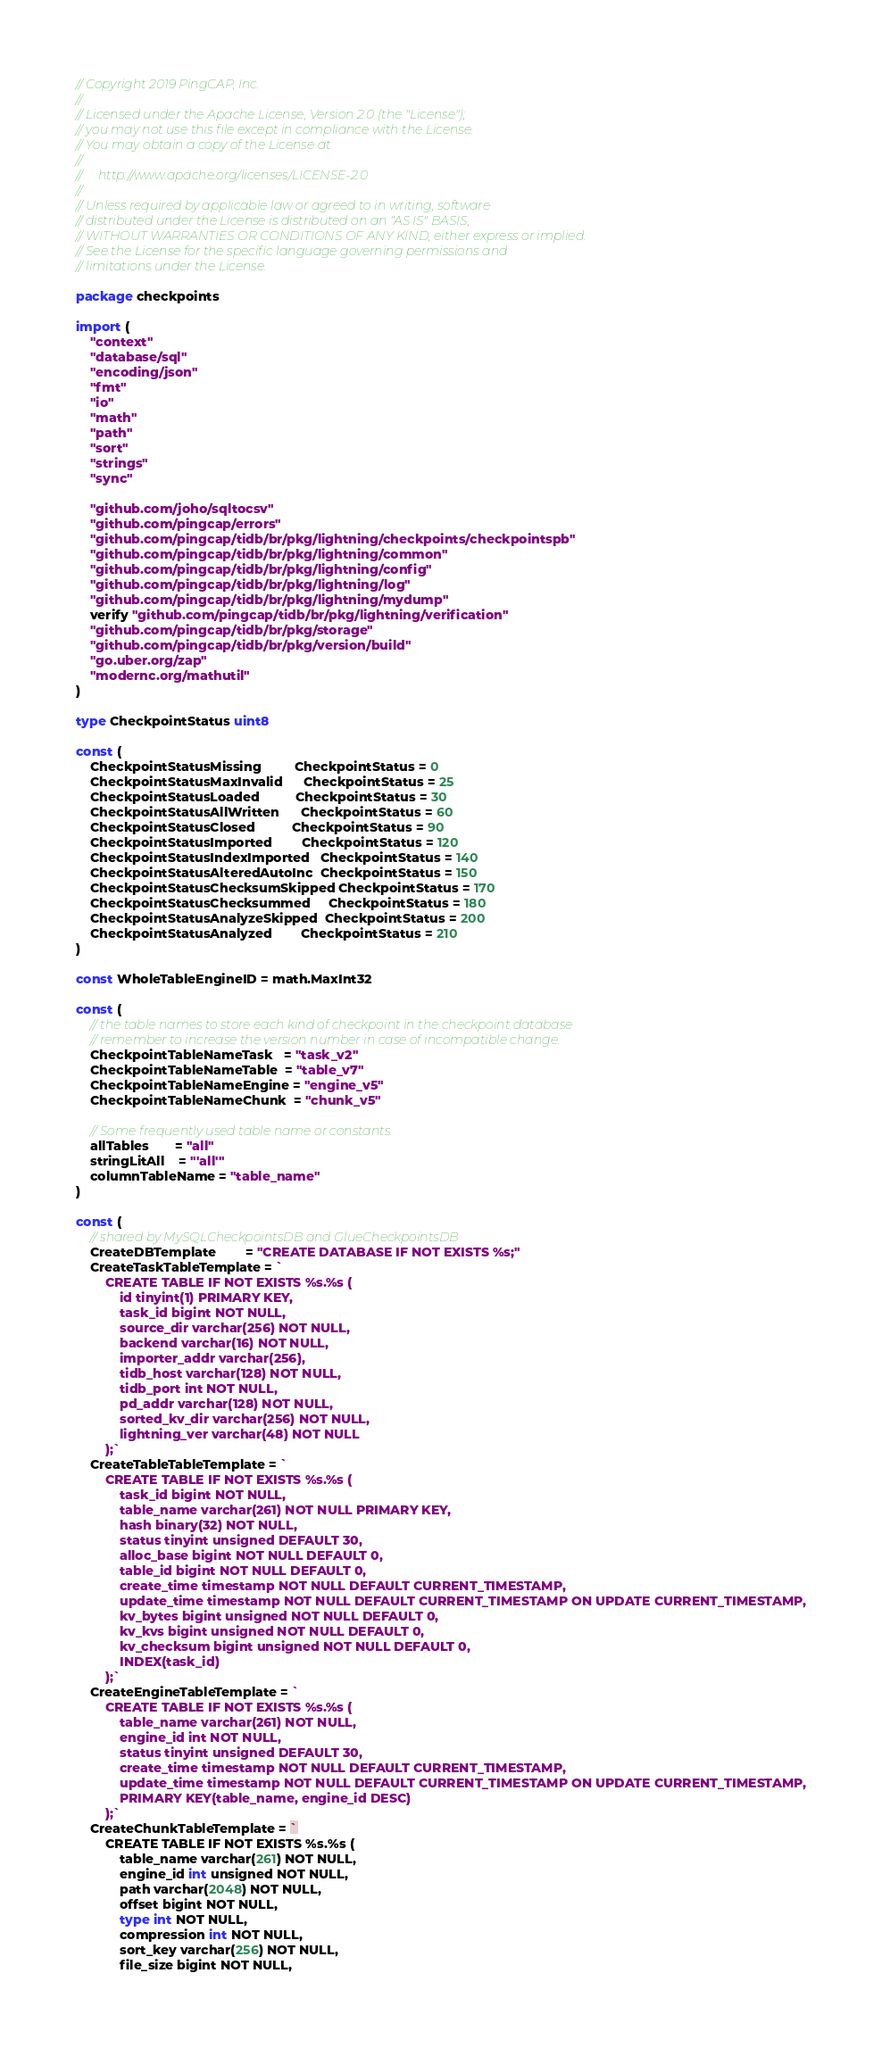Convert code to text. <code><loc_0><loc_0><loc_500><loc_500><_Go_>// Copyright 2019 PingCAP, Inc.
//
// Licensed under the Apache License, Version 2.0 (the "License");
// you may not use this file except in compliance with the License.
// You may obtain a copy of the License at
//
//     http://www.apache.org/licenses/LICENSE-2.0
//
// Unless required by applicable law or agreed to in writing, software
// distributed under the License is distributed on an "AS IS" BASIS,
// WITHOUT WARRANTIES OR CONDITIONS OF ANY KIND, either express or implied.
// See the License for the specific language governing permissions and
// limitations under the License.

package checkpoints

import (
	"context"
	"database/sql"
	"encoding/json"
	"fmt"
	"io"
	"math"
	"path"
	"sort"
	"strings"
	"sync"

	"github.com/joho/sqltocsv"
	"github.com/pingcap/errors"
	"github.com/pingcap/tidb/br/pkg/lightning/checkpoints/checkpointspb"
	"github.com/pingcap/tidb/br/pkg/lightning/common"
	"github.com/pingcap/tidb/br/pkg/lightning/config"
	"github.com/pingcap/tidb/br/pkg/lightning/log"
	"github.com/pingcap/tidb/br/pkg/lightning/mydump"
	verify "github.com/pingcap/tidb/br/pkg/lightning/verification"
	"github.com/pingcap/tidb/br/pkg/storage"
	"github.com/pingcap/tidb/br/pkg/version/build"
	"go.uber.org/zap"
	"modernc.org/mathutil"
)

type CheckpointStatus uint8

const (
	CheckpointStatusMissing         CheckpointStatus = 0
	CheckpointStatusMaxInvalid      CheckpointStatus = 25
	CheckpointStatusLoaded          CheckpointStatus = 30
	CheckpointStatusAllWritten      CheckpointStatus = 60
	CheckpointStatusClosed          CheckpointStatus = 90
	CheckpointStatusImported        CheckpointStatus = 120
	CheckpointStatusIndexImported   CheckpointStatus = 140
	CheckpointStatusAlteredAutoInc  CheckpointStatus = 150
	CheckpointStatusChecksumSkipped CheckpointStatus = 170
	CheckpointStatusChecksummed     CheckpointStatus = 180
	CheckpointStatusAnalyzeSkipped  CheckpointStatus = 200
	CheckpointStatusAnalyzed        CheckpointStatus = 210
)

const WholeTableEngineID = math.MaxInt32

const (
	// the table names to store each kind of checkpoint in the checkpoint database
	// remember to increase the version number in case of incompatible change.
	CheckpointTableNameTask   = "task_v2"
	CheckpointTableNameTable  = "table_v7"
	CheckpointTableNameEngine = "engine_v5"
	CheckpointTableNameChunk  = "chunk_v5"

	// Some frequently used table name or constants.
	allTables       = "all"
	stringLitAll    = "'all'"
	columnTableName = "table_name"
)

const (
	// shared by MySQLCheckpointsDB and GlueCheckpointsDB
	CreateDBTemplate        = "CREATE DATABASE IF NOT EXISTS %s;"
	CreateTaskTableTemplate = `
		CREATE TABLE IF NOT EXISTS %s.%s (
			id tinyint(1) PRIMARY KEY,
			task_id bigint NOT NULL,
			source_dir varchar(256) NOT NULL,
			backend varchar(16) NOT NULL,
			importer_addr varchar(256),
			tidb_host varchar(128) NOT NULL,
			tidb_port int NOT NULL,
			pd_addr varchar(128) NOT NULL,
			sorted_kv_dir varchar(256) NOT NULL,
			lightning_ver varchar(48) NOT NULL
		);`
	CreateTableTableTemplate = `
		CREATE TABLE IF NOT EXISTS %s.%s (
			task_id bigint NOT NULL,
			table_name varchar(261) NOT NULL PRIMARY KEY,
			hash binary(32) NOT NULL,
			status tinyint unsigned DEFAULT 30,
			alloc_base bigint NOT NULL DEFAULT 0,
			table_id bigint NOT NULL DEFAULT 0,
			create_time timestamp NOT NULL DEFAULT CURRENT_TIMESTAMP,
			update_time timestamp NOT NULL DEFAULT CURRENT_TIMESTAMP ON UPDATE CURRENT_TIMESTAMP,
			kv_bytes bigint unsigned NOT NULL DEFAULT 0,
			kv_kvs bigint unsigned NOT NULL DEFAULT 0,
			kv_checksum bigint unsigned NOT NULL DEFAULT 0,
			INDEX(task_id)
		);`
	CreateEngineTableTemplate = `
		CREATE TABLE IF NOT EXISTS %s.%s (
			table_name varchar(261) NOT NULL,
			engine_id int NOT NULL,
			status tinyint unsigned DEFAULT 30,
			create_time timestamp NOT NULL DEFAULT CURRENT_TIMESTAMP,
			update_time timestamp NOT NULL DEFAULT CURRENT_TIMESTAMP ON UPDATE CURRENT_TIMESTAMP,
			PRIMARY KEY(table_name, engine_id DESC)
		);`
	CreateChunkTableTemplate = `
		CREATE TABLE IF NOT EXISTS %s.%s (
			table_name varchar(261) NOT NULL,
			engine_id int unsigned NOT NULL,
			path varchar(2048) NOT NULL,
			offset bigint NOT NULL,
			type int NOT NULL,
			compression int NOT NULL,
			sort_key varchar(256) NOT NULL,
			file_size bigint NOT NULL,</code> 